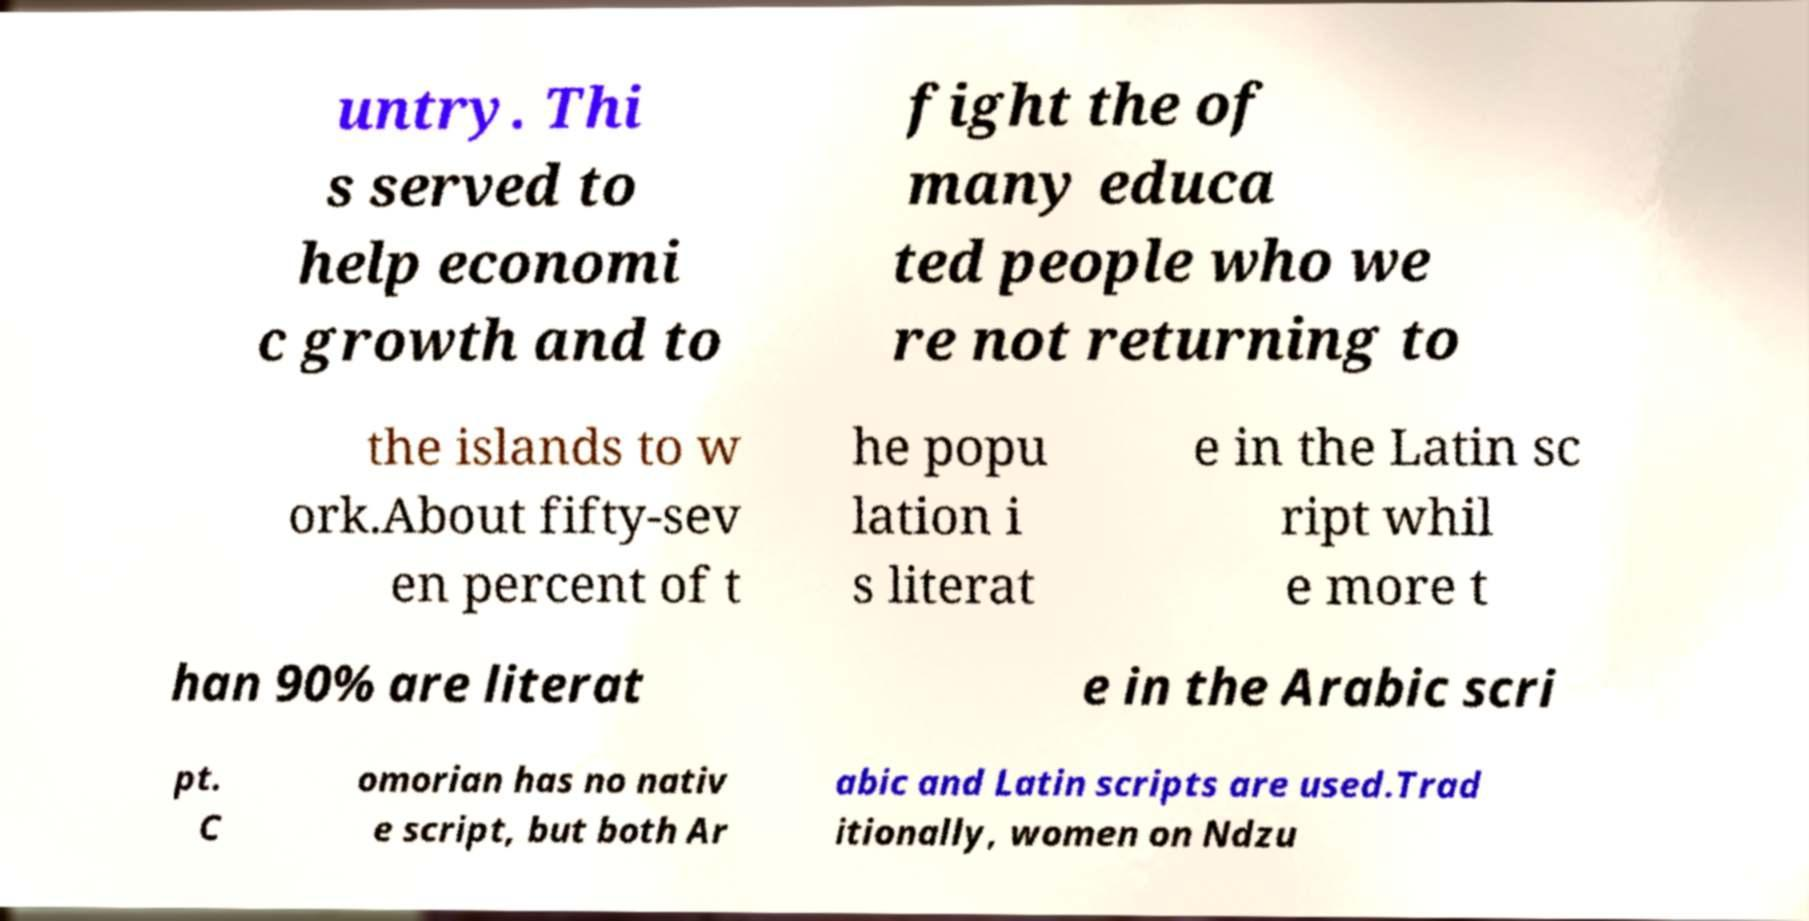Can you accurately transcribe the text from the provided image for me? untry. Thi s served to help economi c growth and to fight the of many educa ted people who we re not returning to the islands to w ork.About fifty-sev en percent of t he popu lation i s literat e in the Latin sc ript whil e more t han 90% are literat e in the Arabic scri pt. C omorian has no nativ e script, but both Ar abic and Latin scripts are used.Trad itionally, women on Ndzu 